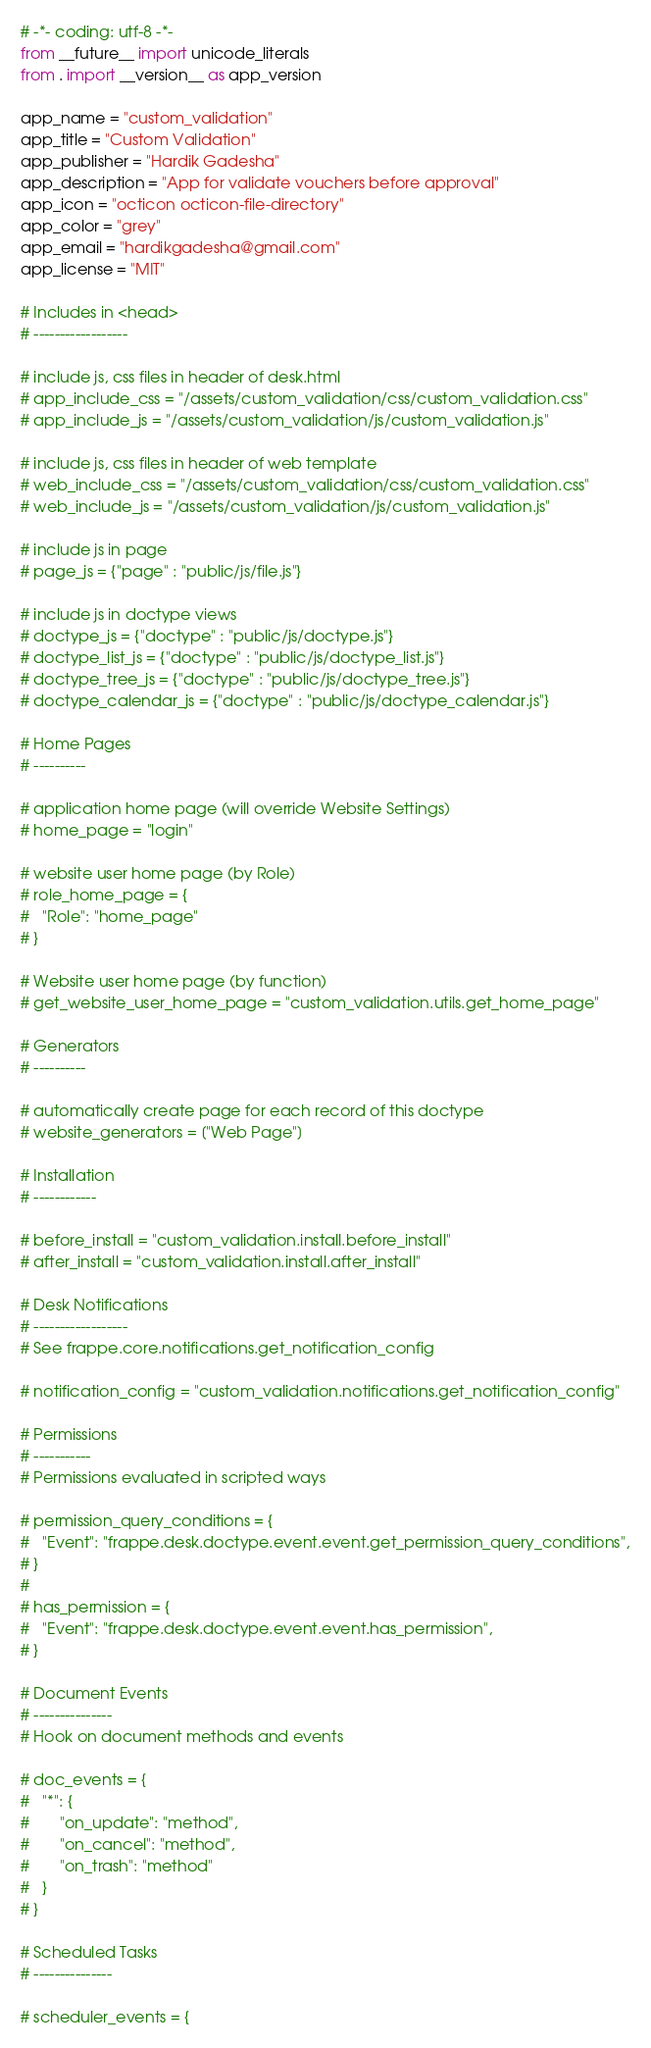Convert code to text. <code><loc_0><loc_0><loc_500><loc_500><_Python_># -*- coding: utf-8 -*-
from __future__ import unicode_literals
from . import __version__ as app_version

app_name = "custom_validation"
app_title = "Custom Validation"
app_publisher = "Hardik Gadesha"
app_description = "App for validate vouchers before approval"
app_icon = "octicon octicon-file-directory"
app_color = "grey"
app_email = "hardikgadesha@gmail.com"
app_license = "MIT"

# Includes in <head>
# ------------------

# include js, css files in header of desk.html
# app_include_css = "/assets/custom_validation/css/custom_validation.css"
# app_include_js = "/assets/custom_validation/js/custom_validation.js"

# include js, css files in header of web template
# web_include_css = "/assets/custom_validation/css/custom_validation.css"
# web_include_js = "/assets/custom_validation/js/custom_validation.js"

# include js in page
# page_js = {"page" : "public/js/file.js"}

# include js in doctype views
# doctype_js = {"doctype" : "public/js/doctype.js"}
# doctype_list_js = {"doctype" : "public/js/doctype_list.js"}
# doctype_tree_js = {"doctype" : "public/js/doctype_tree.js"}
# doctype_calendar_js = {"doctype" : "public/js/doctype_calendar.js"}

# Home Pages
# ----------

# application home page (will override Website Settings)
# home_page = "login"

# website user home page (by Role)
# role_home_page = {
#	"Role": "home_page"
# }

# Website user home page (by function)
# get_website_user_home_page = "custom_validation.utils.get_home_page"

# Generators
# ----------

# automatically create page for each record of this doctype
# website_generators = ["Web Page"]

# Installation
# ------------

# before_install = "custom_validation.install.before_install"
# after_install = "custom_validation.install.after_install"

# Desk Notifications
# ------------------
# See frappe.core.notifications.get_notification_config

# notification_config = "custom_validation.notifications.get_notification_config"

# Permissions
# -----------
# Permissions evaluated in scripted ways

# permission_query_conditions = {
# 	"Event": "frappe.desk.doctype.event.event.get_permission_query_conditions",
# }
#
# has_permission = {
# 	"Event": "frappe.desk.doctype.event.event.has_permission",
# }

# Document Events
# ---------------
# Hook on document methods and events

# doc_events = {
# 	"*": {
# 		"on_update": "method",
# 		"on_cancel": "method",
# 		"on_trash": "method"
#	}
# }

# Scheduled Tasks
# ---------------

# scheduler_events = {</code> 